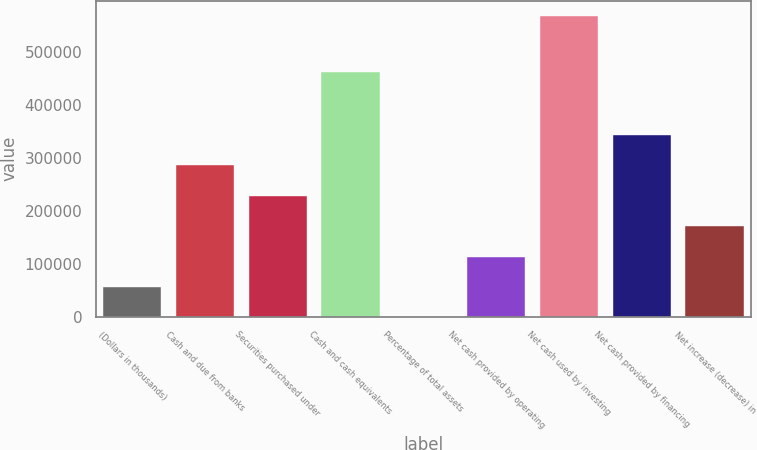<chart> <loc_0><loc_0><loc_500><loc_500><bar_chart><fcel>(Dollars in thousands)<fcel>Cash and due from banks<fcel>Securities purchased under<fcel>Cash and cash equivalents<fcel>Percentage of total assets<fcel>Net cash provided by operating<fcel>Net cash used by investing<fcel>Net cash provided by financing<fcel>Net increase (decrease) in<nl><fcel>56796.8<fcel>286446<fcel>227162<fcel>462098<fcel>8.3<fcel>113585<fcel>567893<fcel>343234<fcel>170374<nl></chart> 